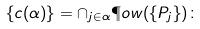Convert formula to latex. <formula><loc_0><loc_0><loc_500><loc_500>\{ c ( \alpha ) \} = \cap _ { j \in \alpha } \P o w ( \{ P _ { j } \} ) \colon</formula> 